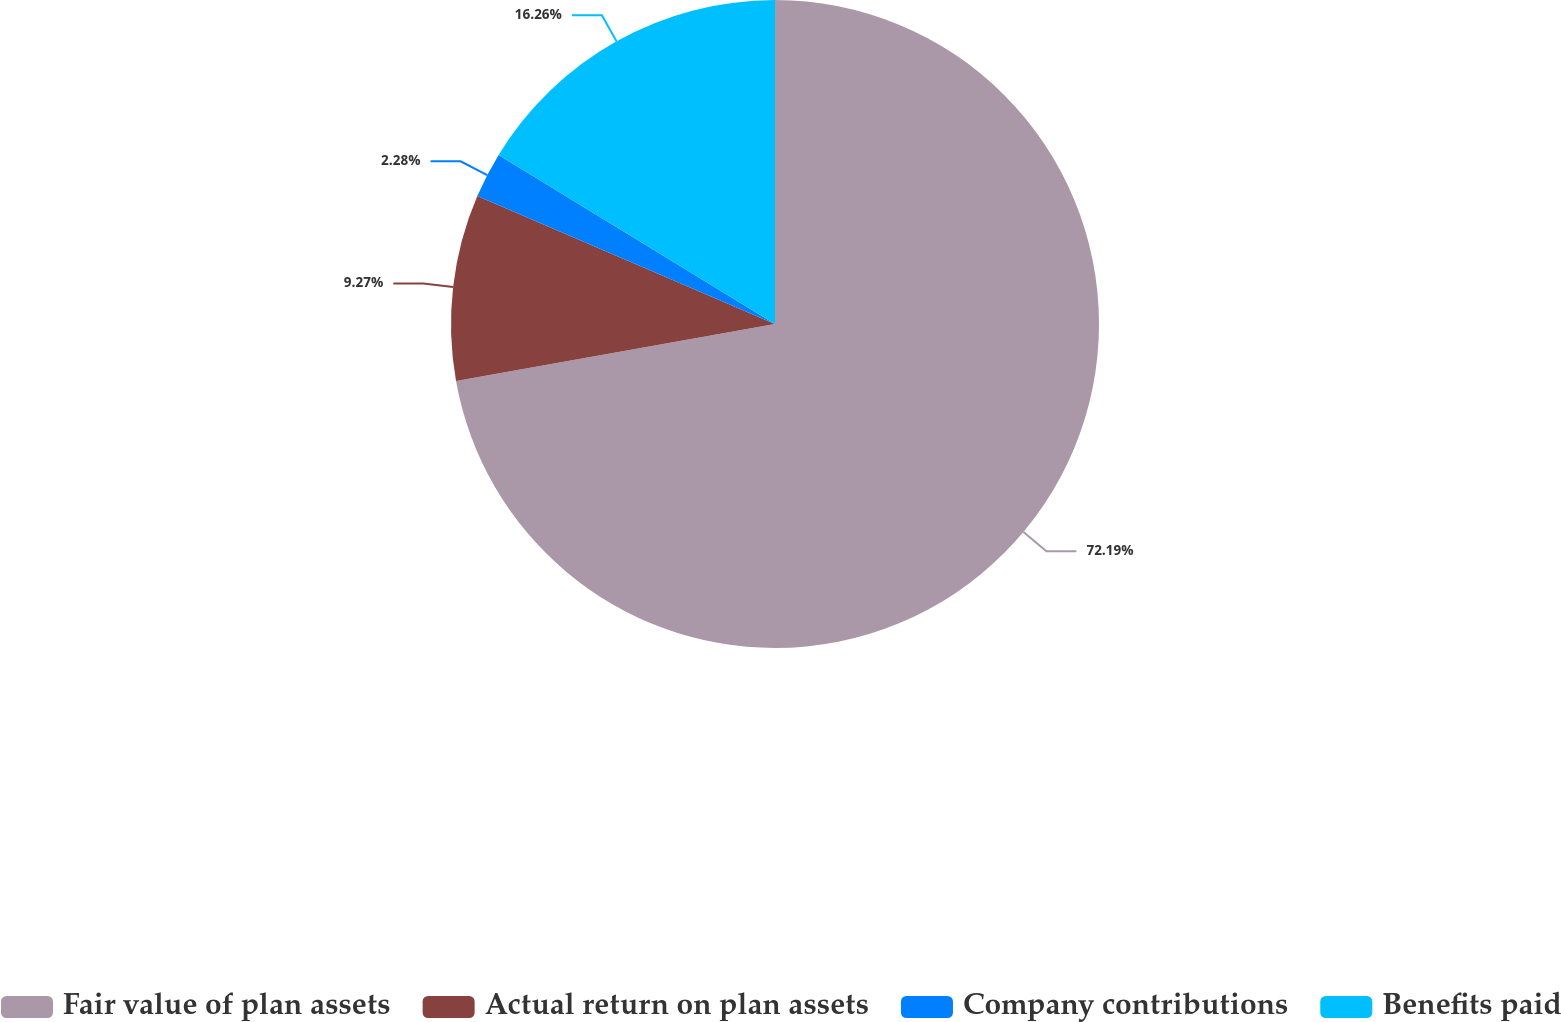Convert chart. <chart><loc_0><loc_0><loc_500><loc_500><pie_chart><fcel>Fair value of plan assets<fcel>Actual return on plan assets<fcel>Company contributions<fcel>Benefits paid<nl><fcel>72.18%<fcel>9.27%<fcel>2.28%<fcel>16.26%<nl></chart> 